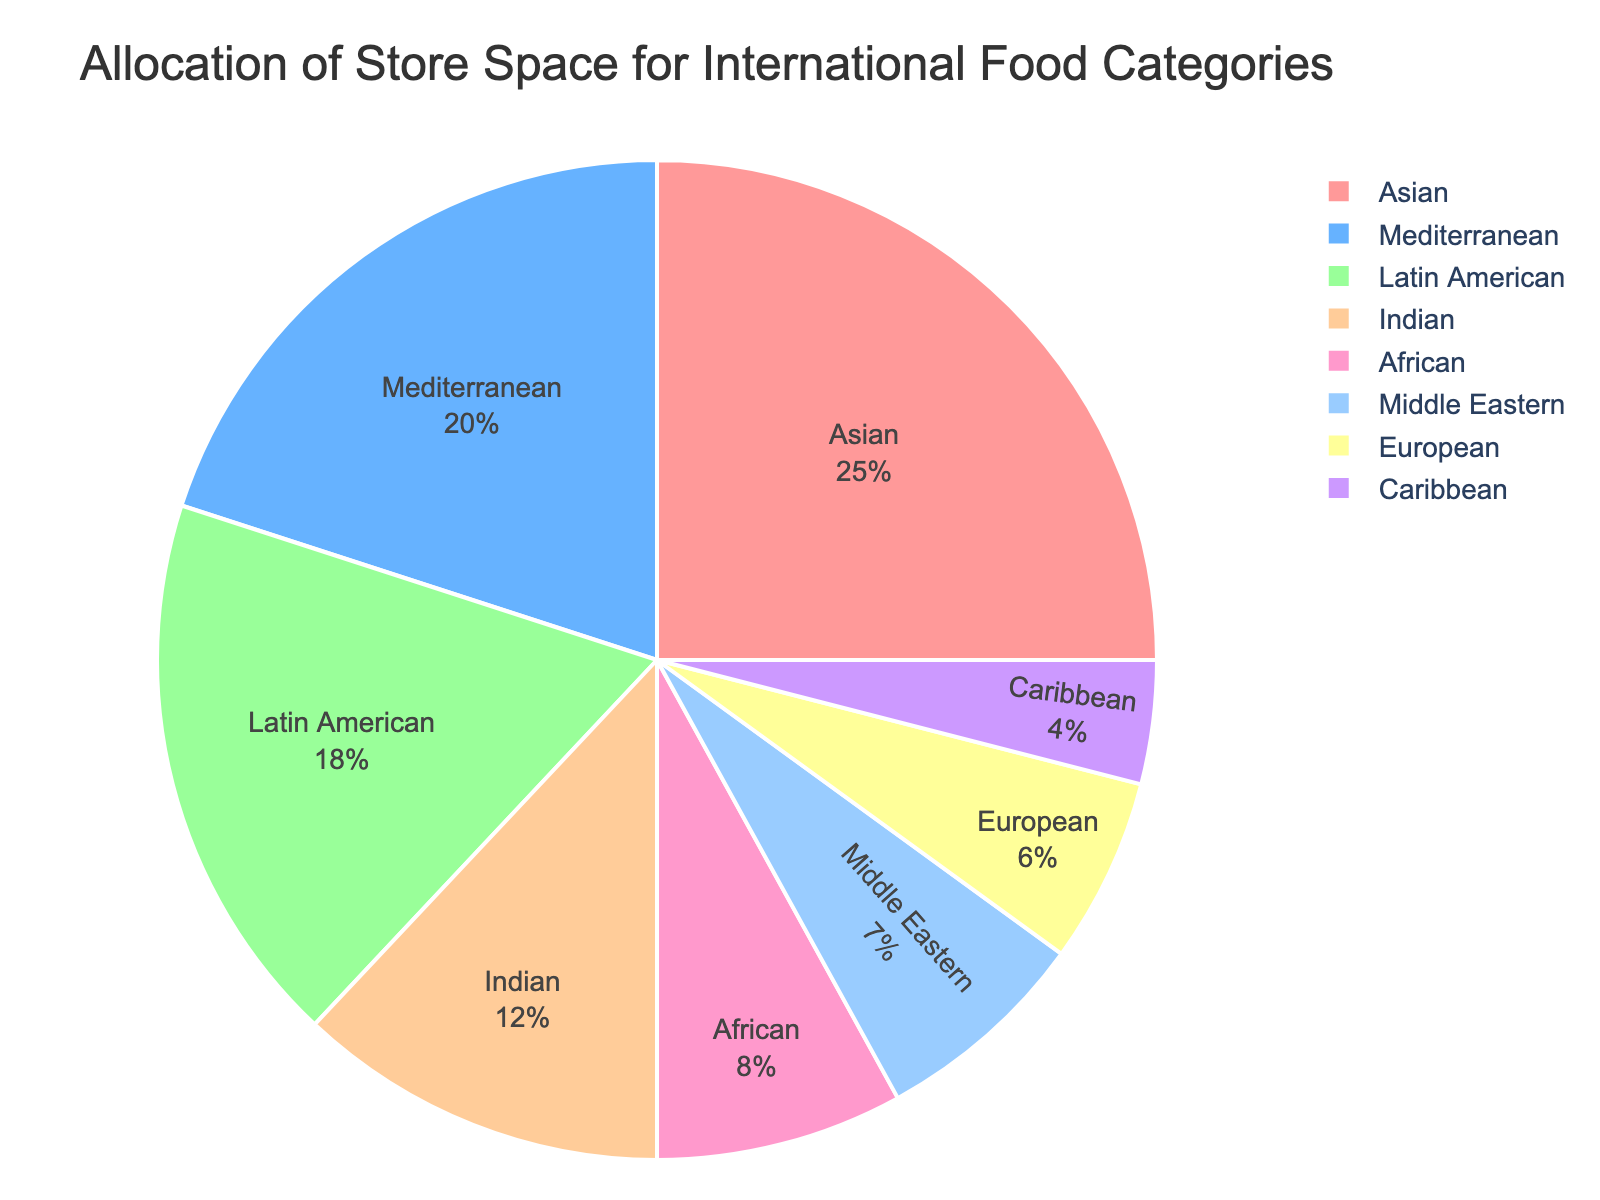1. Which category takes up the largest store space? The pie chart shows the percentages of store space allocated to different international food categories. The largest slice represents 25%, which is labeled as "Asian."
Answer: Asian 2. What is the combined store space percentage for Latin American and Caribbean categories? Find the slices labeled "Latin American" and "Caribbean" on the pie chart and sum their percentages: 18% + 4% = 22%.
Answer: 22% 3. How much more store space is allocated to Indian food compared to Caribbean food? Subtract the percentage allocated to Caribbean (4%) from the percentage allocated to Indian (12%): 12% - 4% = 8%.
Answer: 8% 4. Which categories together make up less than 15% of the store space? Find the slices with percentages less than 15%. These are "African" (8%), "Middle Eastern" (7%), "European" (6%), and "Caribbean" (4%).
Answer: African, Middle Eastern, European, Caribbean 5. What percentage of the store space is allocated to categories that each take up more than 20%? Look for slices larger than 20%. The "Asian" (25%) and "Mediterranean" (20%) food categories meet this criterion.
Answer: 45% (25% + 20%) 6. If the store plans to expand the space for Mediterranean foods by 5%, what will the new percentage be? Add 5% to the current percentage for Mediterranean foods: 20% + 5% = 25%.
Answer: 25% 7. Which category's store space percentage is closest to the average store space percentage of all the categories? First, calculate the average percentage: (25% + 20% + 18% + 12% + 8% + 7% + 6% + 4%) / 8 = 100% / 8 = 12.5%. The closest values are "Indian" (12%) and "African" (8%).
Answer: Indian 8. Is the space allocated to Latin American foods greater than the combined space for Middle Eastern and European foods? Compare the percentage for Latin American (18%) with the sum of Middle Eastern (7%) and European (6%): 18% > (7% + 6% = 13%).
Answer: Yes 9. What is the total percentage of store space allocated to African and Middle Eastern categories combined? Sum the percentages allocated to African and Middle Eastern food categories: 8% + 7% = 15%.
Answer: 15% 10. If equal space were to be redistributed from Asian to Caribbean foods to make their percentages equal, what would each of their new percentages be? Let "x" be the amount of space transferred. To equalize, we need 25% - x = 4% + x. Solving 21% = 2x gives x = 10.5%. Thus, Asian = 25% - 10.5% = 14.5% and Caribbean = 4% + 10.5% = 14.5%.
Answer: 14.5% each 